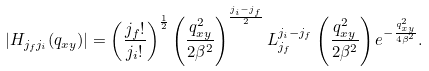<formula> <loc_0><loc_0><loc_500><loc_500>| H _ { j _ { f } j _ { i } } ( q _ { x y } ) | = \left ( \frac { j _ { f } ! } { j _ { i } ! } \right ) ^ { \frac { 1 } { 2 } } \left ( \frac { q _ { x y } ^ { 2 } } { 2 \beta ^ { 2 } } \right ) ^ { \frac { j _ { i } - j _ { f } } { 2 } } L _ { j _ { f } } ^ { j _ { i } - j _ { f } } \left ( \frac { q _ { x y } ^ { 2 } } { 2 \beta ^ { 2 } } \right ) e ^ { - \frac { q _ { x y } ^ { 2 } } { 4 \beta ^ { 2 } } } .</formula> 